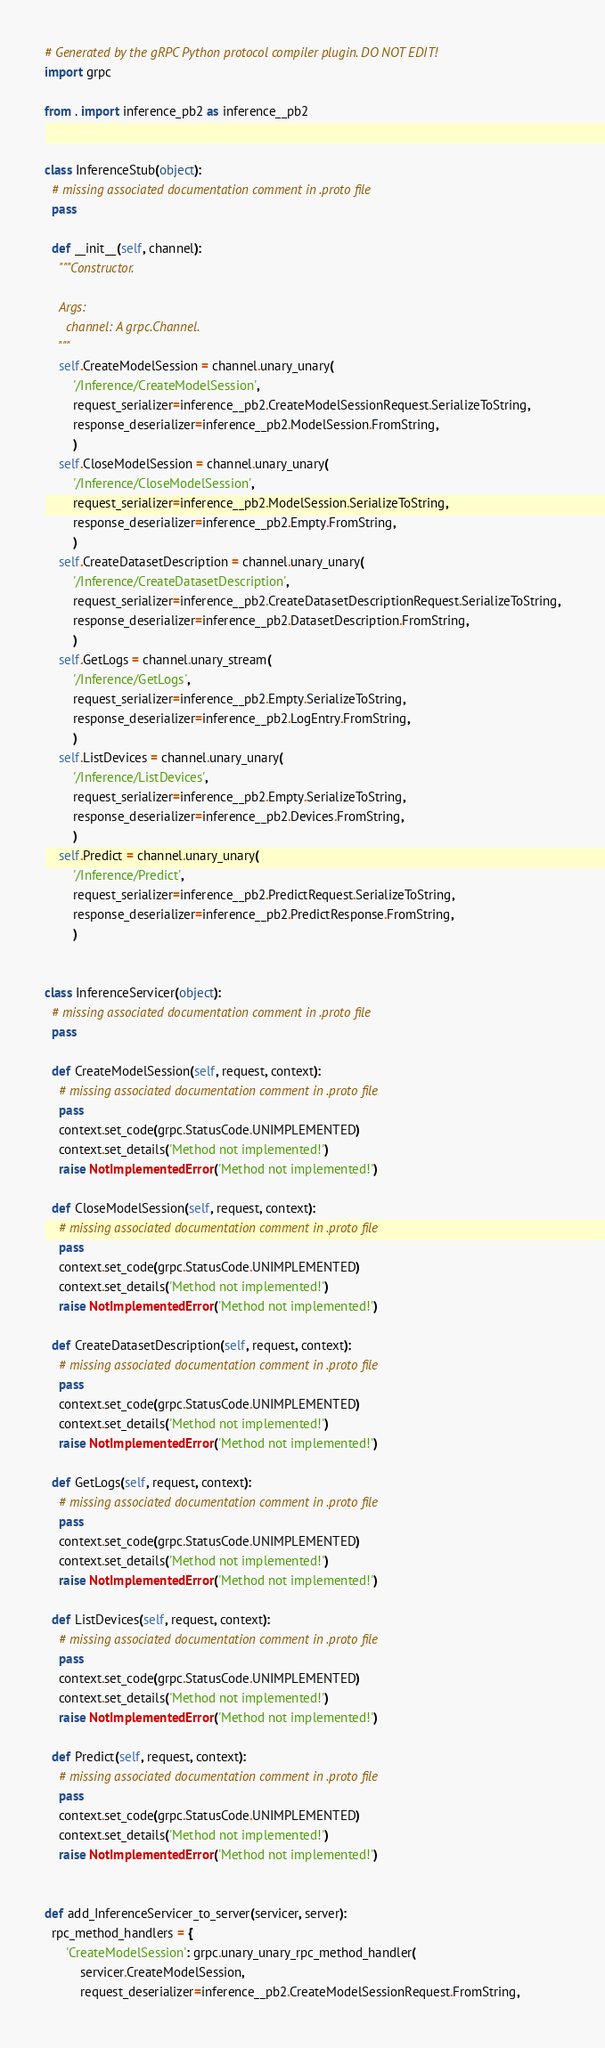<code> <loc_0><loc_0><loc_500><loc_500><_Python_># Generated by the gRPC Python protocol compiler plugin. DO NOT EDIT!
import grpc

from . import inference_pb2 as inference__pb2


class InferenceStub(object):
  # missing associated documentation comment in .proto file
  pass

  def __init__(self, channel):
    """Constructor.

    Args:
      channel: A grpc.Channel.
    """
    self.CreateModelSession = channel.unary_unary(
        '/Inference/CreateModelSession',
        request_serializer=inference__pb2.CreateModelSessionRequest.SerializeToString,
        response_deserializer=inference__pb2.ModelSession.FromString,
        )
    self.CloseModelSession = channel.unary_unary(
        '/Inference/CloseModelSession',
        request_serializer=inference__pb2.ModelSession.SerializeToString,
        response_deserializer=inference__pb2.Empty.FromString,
        )
    self.CreateDatasetDescription = channel.unary_unary(
        '/Inference/CreateDatasetDescription',
        request_serializer=inference__pb2.CreateDatasetDescriptionRequest.SerializeToString,
        response_deserializer=inference__pb2.DatasetDescription.FromString,
        )
    self.GetLogs = channel.unary_stream(
        '/Inference/GetLogs',
        request_serializer=inference__pb2.Empty.SerializeToString,
        response_deserializer=inference__pb2.LogEntry.FromString,
        )
    self.ListDevices = channel.unary_unary(
        '/Inference/ListDevices',
        request_serializer=inference__pb2.Empty.SerializeToString,
        response_deserializer=inference__pb2.Devices.FromString,
        )
    self.Predict = channel.unary_unary(
        '/Inference/Predict',
        request_serializer=inference__pb2.PredictRequest.SerializeToString,
        response_deserializer=inference__pb2.PredictResponse.FromString,
        )


class InferenceServicer(object):
  # missing associated documentation comment in .proto file
  pass

  def CreateModelSession(self, request, context):
    # missing associated documentation comment in .proto file
    pass
    context.set_code(grpc.StatusCode.UNIMPLEMENTED)
    context.set_details('Method not implemented!')
    raise NotImplementedError('Method not implemented!')

  def CloseModelSession(self, request, context):
    # missing associated documentation comment in .proto file
    pass
    context.set_code(grpc.StatusCode.UNIMPLEMENTED)
    context.set_details('Method not implemented!')
    raise NotImplementedError('Method not implemented!')

  def CreateDatasetDescription(self, request, context):
    # missing associated documentation comment in .proto file
    pass
    context.set_code(grpc.StatusCode.UNIMPLEMENTED)
    context.set_details('Method not implemented!')
    raise NotImplementedError('Method not implemented!')

  def GetLogs(self, request, context):
    # missing associated documentation comment in .proto file
    pass
    context.set_code(grpc.StatusCode.UNIMPLEMENTED)
    context.set_details('Method not implemented!')
    raise NotImplementedError('Method not implemented!')

  def ListDevices(self, request, context):
    # missing associated documentation comment in .proto file
    pass
    context.set_code(grpc.StatusCode.UNIMPLEMENTED)
    context.set_details('Method not implemented!')
    raise NotImplementedError('Method not implemented!')

  def Predict(self, request, context):
    # missing associated documentation comment in .proto file
    pass
    context.set_code(grpc.StatusCode.UNIMPLEMENTED)
    context.set_details('Method not implemented!')
    raise NotImplementedError('Method not implemented!')


def add_InferenceServicer_to_server(servicer, server):
  rpc_method_handlers = {
      'CreateModelSession': grpc.unary_unary_rpc_method_handler(
          servicer.CreateModelSession,
          request_deserializer=inference__pb2.CreateModelSessionRequest.FromString,</code> 